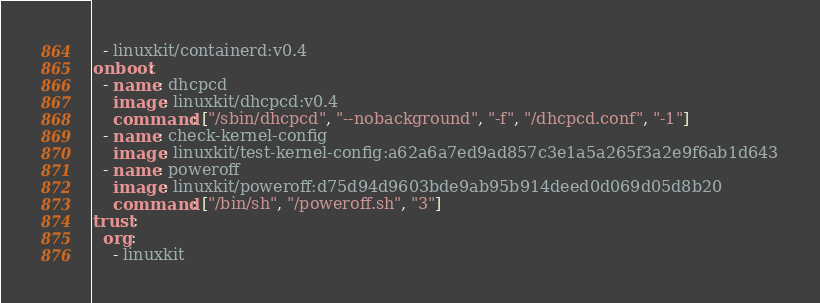Convert code to text. <code><loc_0><loc_0><loc_500><loc_500><_YAML_>  - linuxkit/containerd:v0.4
onboot:
  - name: dhcpcd
    image: linuxkit/dhcpcd:v0.4
    command: ["/sbin/dhcpcd", "--nobackground", "-f", "/dhcpcd.conf", "-1"]
  - name: check-kernel-config
    image: linuxkit/test-kernel-config:a62a6a7ed9ad857c3e1a5a265f3a2e9f6ab1d643
  - name: poweroff
    image: linuxkit/poweroff:d75d94d9603bde9ab95b914deed0d069d05d8b20
    command: ["/bin/sh", "/poweroff.sh", "3"]
trust:
  org:
    - linuxkit
</code> 